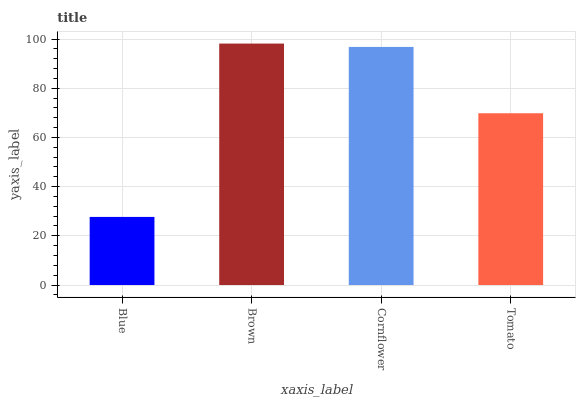Is Blue the minimum?
Answer yes or no. Yes. Is Brown the maximum?
Answer yes or no. Yes. Is Cornflower the minimum?
Answer yes or no. No. Is Cornflower the maximum?
Answer yes or no. No. Is Brown greater than Cornflower?
Answer yes or no. Yes. Is Cornflower less than Brown?
Answer yes or no. Yes. Is Cornflower greater than Brown?
Answer yes or no. No. Is Brown less than Cornflower?
Answer yes or no. No. Is Cornflower the high median?
Answer yes or no. Yes. Is Tomato the low median?
Answer yes or no. Yes. Is Brown the high median?
Answer yes or no. No. Is Brown the low median?
Answer yes or no. No. 